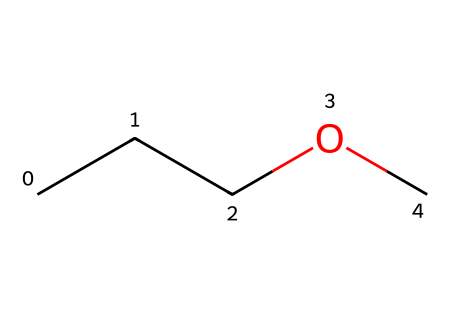What is the molecular formula of ethyl propyl ether? The chemical structure indicates that there are three carbon atoms (C), eight hydrogen atoms (H), and one oxygen atom (O). Thus, the molecular formula can be deduced as C3H8O.
Answer: C3H8O How many carbon atoms are present in the structure? By examining the structure, we see a straight chain of three carbon atoms represented within the SMILES. Thus, the count of carbon atoms is three.
Answer: 3 What functional group is present in ethyl propyl ether? The SMILES notation contains an ether group where the oxygen atom (O) is bonded to two carbon chains (ethyl and propyl). This indicates the ether functional group.
Answer: ether Is ethyl propyl ether a saturated or unsaturated compound? The absence of double or triple bonds in the chemical structure indicates that all carbon atoms are fully bonded to hydrogen atoms, classifying it as saturated.
Answer: saturated What is the total number of atoms in ethyl propyl ether? The total atom count combines the 3 carbon (C), 8 hydrogen (H), and 1 oxygen (O) atom, resulting in 12 atoms overall. This is summed as 3 + 8 + 1.
Answer: 12 Does ethyl propyl ether have a cyclic structure? By analyzing the SMILES, it's evident that the carbon atoms are linear, with no indication of a ring in the molecular structure; hence it is not cyclic.
Answer: no 